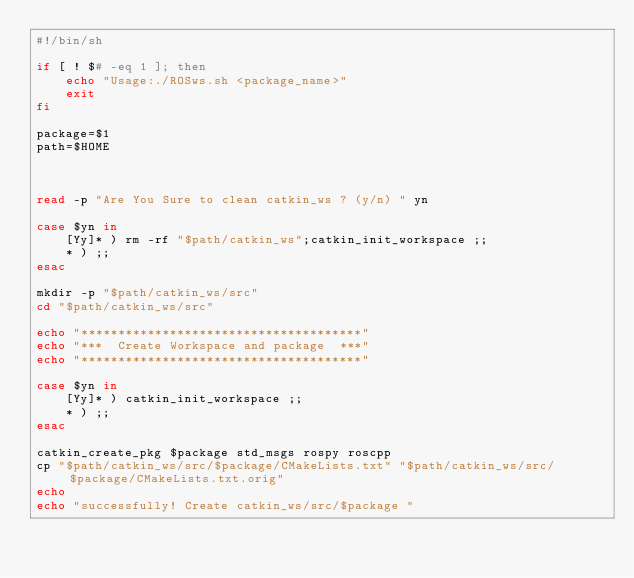<code> <loc_0><loc_0><loc_500><loc_500><_Bash_>#!/bin/sh

if [ ! $# -eq 1 ]; then
	echo "Usage:./ROSws.sh <package_name>"
	exit
fi

package=$1
path=$HOME



read -p "Are You Sure to clean catkin_ws ? (y/n) " yn

case $yn in
	[Yy]* ) rm -rf "$path/catkin_ws";catkin_init_workspace ;;
	* ) ;;
esac

mkdir -p "$path/catkin_ws/src"
cd "$path/catkin_ws/src"

echo "**************************************"
echo "***  Create Workspace and package  ***"
echo "**************************************"

case $yn in
	[Yy]* ) catkin_init_workspace ;;
	* ) ;;
esac

catkin_create_pkg $package std_msgs rospy roscpp
cp "$path/catkin_ws/src/$package/CMakeLists.txt" "$path/catkin_ws/src/$package/CMakeLists.txt.orig"
echo 
echo "successfully! Create catkin_ws/src/$package "


</code> 